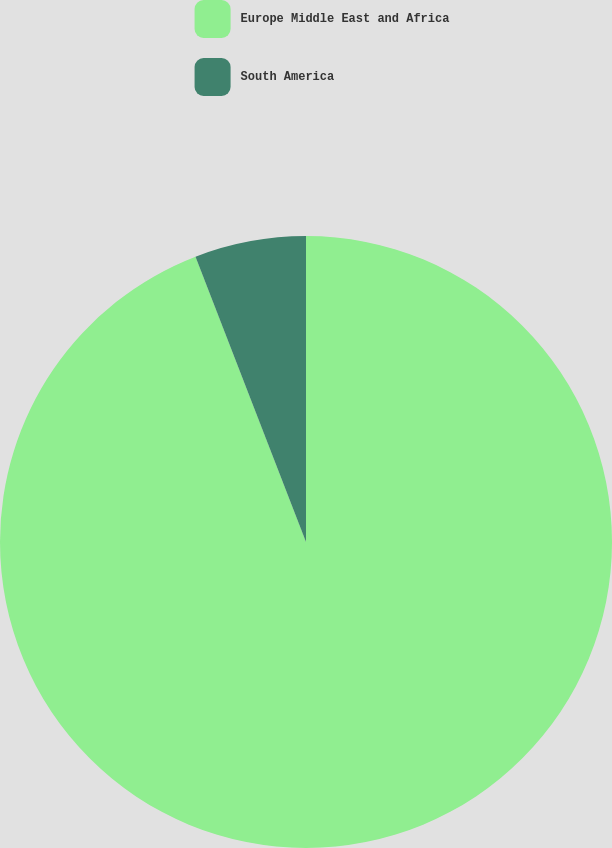<chart> <loc_0><loc_0><loc_500><loc_500><pie_chart><fcel>Europe Middle East and Africa<fcel>South America<nl><fcel>94.12%<fcel>5.88%<nl></chart> 